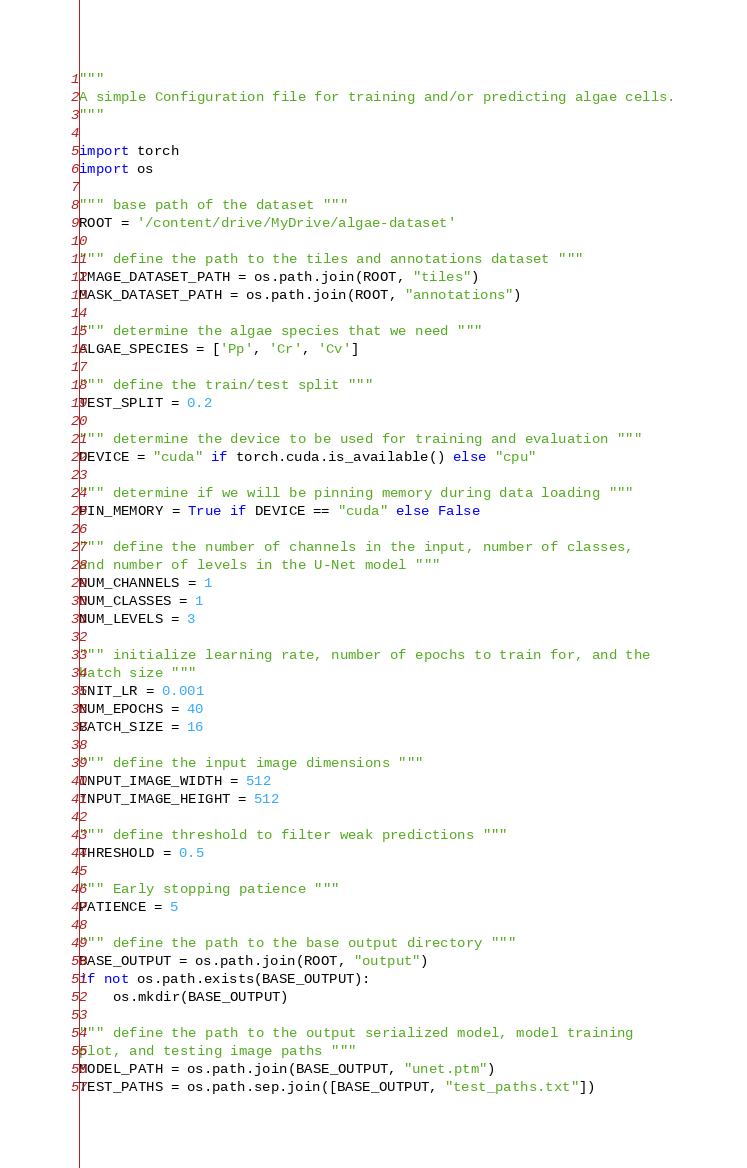<code> <loc_0><loc_0><loc_500><loc_500><_Python_>"""
A simple Configuration file for training and/or predicting algae cells.
"""

import torch
import os

""" base path of the dataset """
ROOT = '/content/drive/MyDrive/algae-dataset'

""" define the path to the tiles and annotations dataset """
IMAGE_DATASET_PATH = os.path.join(ROOT, "tiles")
MASK_DATASET_PATH = os.path.join(ROOT, "annotations")

""" determine the algae species that we need """
ALGAE_SPECIES = ['Pp', 'Cr', 'Cv']

""" define the train/test split """
TEST_SPLIT = 0.2

""" determine the device to be used for training and evaluation """
DEVICE = "cuda" if torch.cuda.is_available() else "cpu"

""" determine if we will be pinning memory during data loading """
PIN_MEMORY = True if DEVICE == "cuda" else False

""" define the number of channels in the input, number of classes,
and number of levels in the U-Net model """
NUM_CHANNELS = 1
NUM_CLASSES = 1
NUM_LEVELS = 3

""" initialize learning rate, number of epochs to train for, and the
batch size """
INIT_LR = 0.001
NUM_EPOCHS = 40
BATCH_SIZE = 16

""" define the input image dimensions """
INPUT_IMAGE_WIDTH = 512
INPUT_IMAGE_HEIGHT = 512

""" define threshold to filter weak predictions """
THRESHOLD = 0.5

""" Early stopping patience """
PATIENCE = 5

""" define the path to the base output directory """
BASE_OUTPUT = os.path.join(ROOT, "output")
if not os.path.exists(BASE_OUTPUT):
    os.mkdir(BASE_OUTPUT)

""" define the path to the output serialized model, model training
plot, and testing image paths """
MODEL_PATH = os.path.join(BASE_OUTPUT, "unet.ptm")
TEST_PATHS = os.path.sep.join([BASE_OUTPUT, "test_paths.txt"])
</code> 